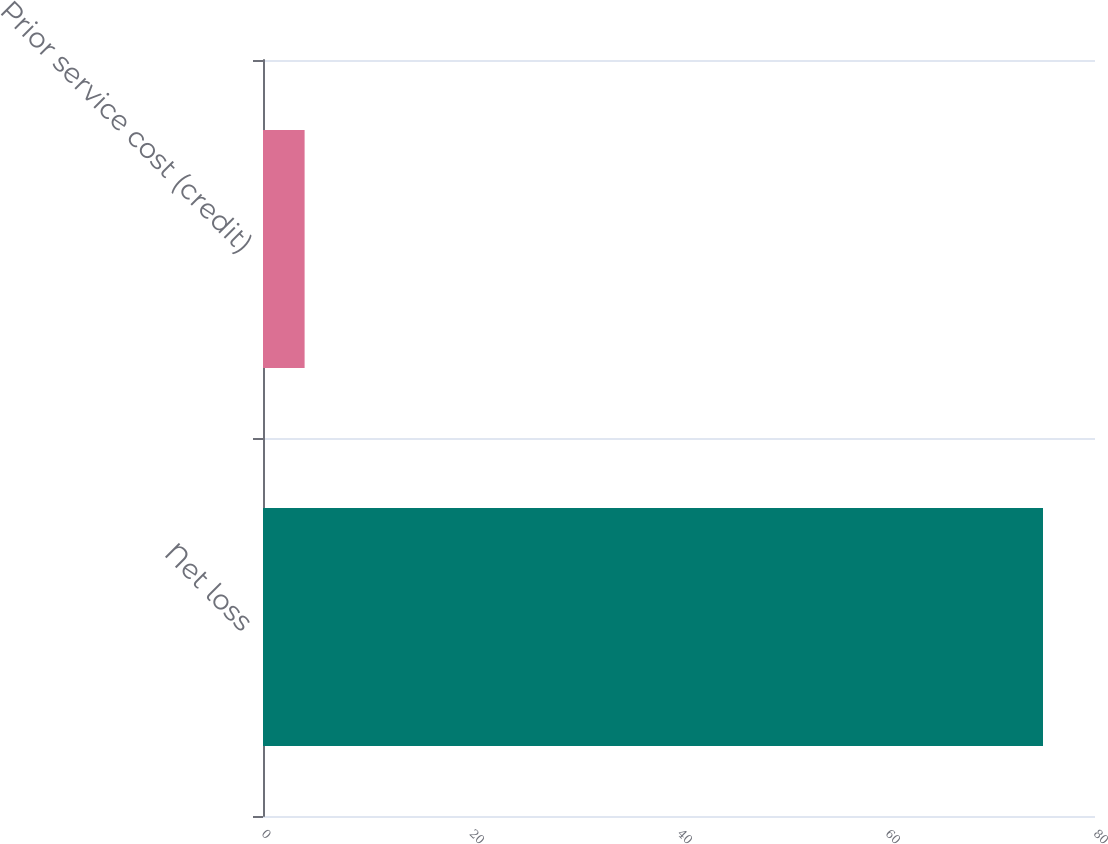<chart> <loc_0><loc_0><loc_500><loc_500><bar_chart><fcel>Net loss<fcel>Prior service cost (credit)<nl><fcel>75<fcel>4<nl></chart> 